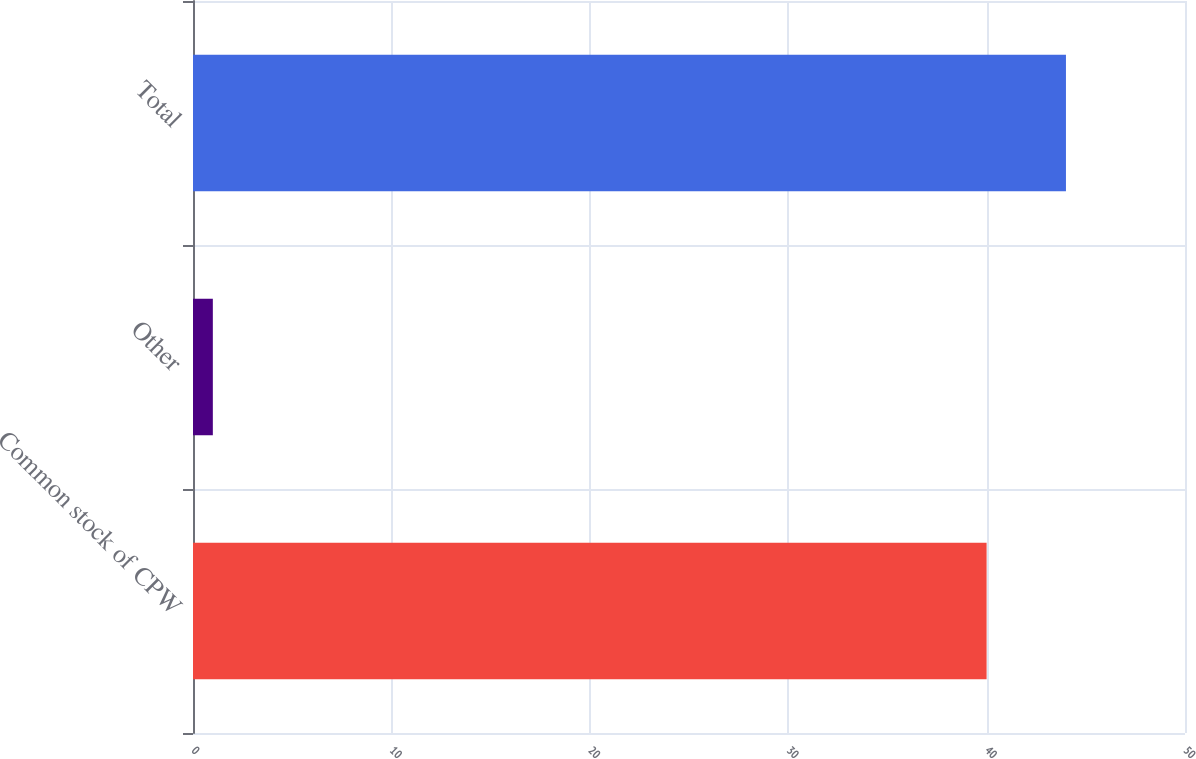Convert chart. <chart><loc_0><loc_0><loc_500><loc_500><bar_chart><fcel>Common stock of CPW<fcel>Other<fcel>Total<nl><fcel>40<fcel>1<fcel>44<nl></chart> 